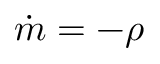Convert formula to latex. <formula><loc_0><loc_0><loc_500><loc_500>{ \dot { m } } = - \rho</formula> 